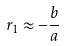Convert formula to latex. <formula><loc_0><loc_0><loc_500><loc_500>r _ { 1 } \approx - \frac { b } { a }</formula> 